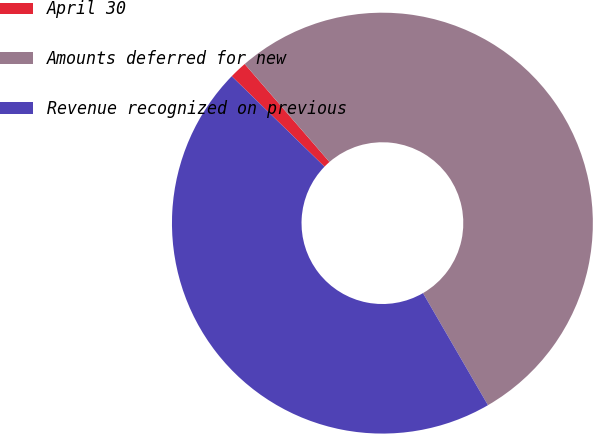Convert chart. <chart><loc_0><loc_0><loc_500><loc_500><pie_chart><fcel>April 30<fcel>Amounts deferred for new<fcel>Revenue recognized on previous<nl><fcel>1.35%<fcel>52.99%<fcel>45.66%<nl></chart> 